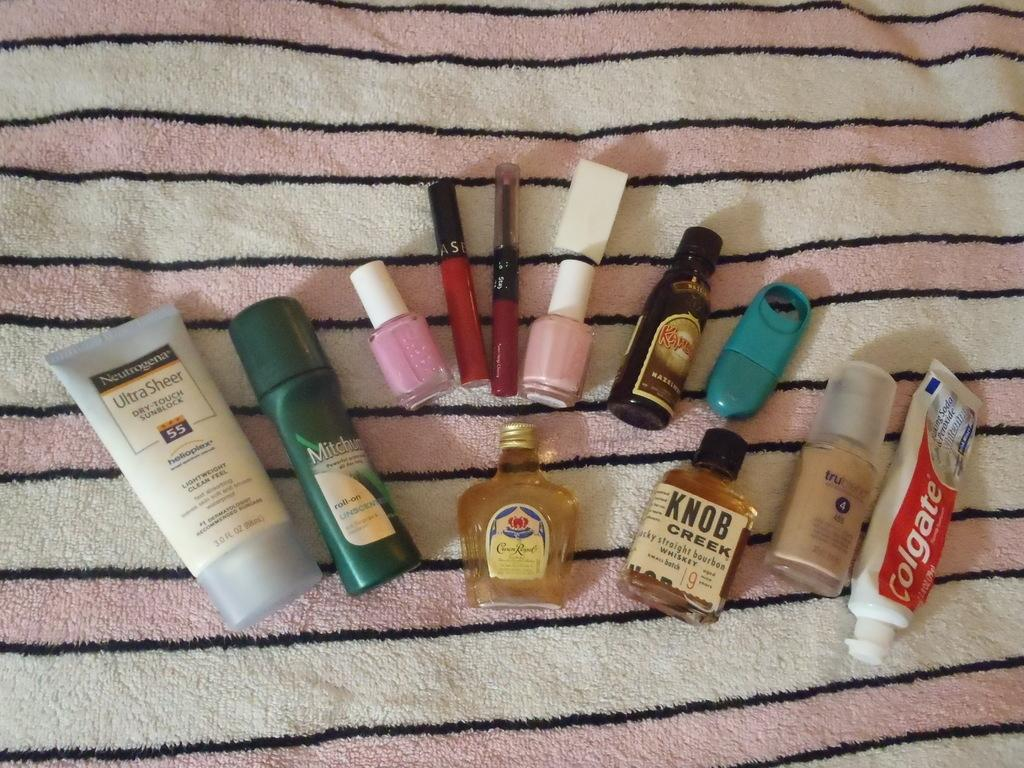What is the primary setting of the image? The primary setting of the image is a table. What can be found on the table in the image? There are objects on the table in the image. Can you describe any specific details about the objects on the table? There is text written on at least one of the objects. What type of card can be seen being used to generate power downtown in the image? There is no card or downtown location present in the image. 